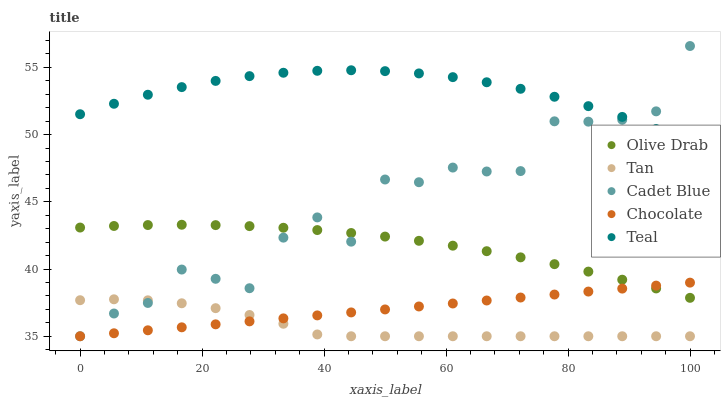Does Tan have the minimum area under the curve?
Answer yes or no. Yes. Does Teal have the maximum area under the curve?
Answer yes or no. Yes. Does Cadet Blue have the minimum area under the curve?
Answer yes or no. No. Does Cadet Blue have the maximum area under the curve?
Answer yes or no. No. Is Chocolate the smoothest?
Answer yes or no. Yes. Is Cadet Blue the roughest?
Answer yes or no. Yes. Is Teal the smoothest?
Answer yes or no. No. Is Teal the roughest?
Answer yes or no. No. Does Tan have the lowest value?
Answer yes or no. Yes. Does Teal have the lowest value?
Answer yes or no. No. Does Cadet Blue have the highest value?
Answer yes or no. Yes. Does Teal have the highest value?
Answer yes or no. No. Is Olive Drab less than Teal?
Answer yes or no. Yes. Is Teal greater than Olive Drab?
Answer yes or no. Yes. Does Olive Drab intersect Chocolate?
Answer yes or no. Yes. Is Olive Drab less than Chocolate?
Answer yes or no. No. Is Olive Drab greater than Chocolate?
Answer yes or no. No. Does Olive Drab intersect Teal?
Answer yes or no. No. 